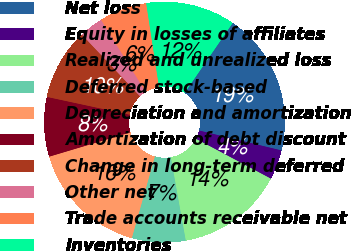<chart> <loc_0><loc_0><loc_500><loc_500><pie_chart><fcel>Net loss<fcel>Equity in losses of affiliates<fcel>Realized and unrealized loss<fcel>Deferred stock-based<fcel>Depreciation and amortization<fcel>Amortization of debt discount<fcel>Change in long-term deferred<fcel>Other net<fcel>Trade accounts receivable net<fcel>Inventories<nl><fcel>19.2%<fcel>4.0%<fcel>14.4%<fcel>7.2%<fcel>16.0%<fcel>8.0%<fcel>9.6%<fcel>3.2%<fcel>6.4%<fcel>12.0%<nl></chart> 